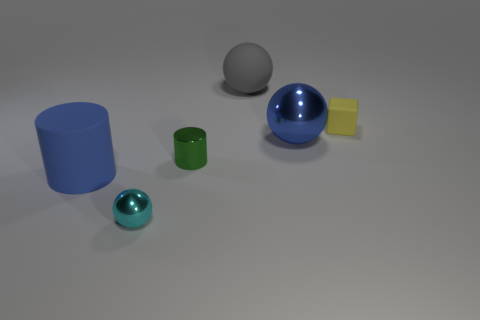Does the large metal thing have the same color as the big cylinder?
Your response must be concise. Yes. There is a ball that is the same color as the big cylinder; what is its material?
Your answer should be very brief. Metal. What number of cylinders have the same color as the big metal thing?
Keep it short and to the point. 1. There is a matte thing left of the small green metallic object; is it the same color as the metal object that is behind the tiny green metal thing?
Your response must be concise. Yes. There is a green shiny cylinder; are there any tiny metal things behind it?
Provide a succinct answer. No. What is the small object that is both left of the yellow thing and behind the tiny cyan metal sphere made of?
Your response must be concise. Metal. Do the thing that is on the right side of the blue shiny thing and the large gray thing have the same material?
Offer a very short reply. Yes. What material is the green object?
Offer a very short reply. Metal. How big is the sphere in front of the blue metal sphere?
Offer a very short reply. Small. Is there anything else of the same color as the rubber ball?
Provide a short and direct response. No. 